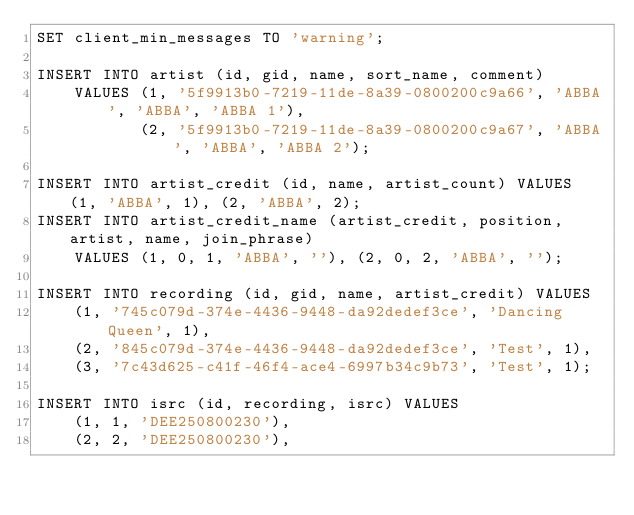Convert code to text. <code><loc_0><loc_0><loc_500><loc_500><_SQL_>SET client_min_messages TO 'warning';

INSERT INTO artist (id, gid, name, sort_name, comment)
    VALUES (1, '5f9913b0-7219-11de-8a39-0800200c9a66', 'ABBA', 'ABBA', 'ABBA 1'),
           (2, '5f9913b0-7219-11de-8a39-0800200c9a67', 'ABBA', 'ABBA', 'ABBA 2');

INSERT INTO artist_credit (id, name, artist_count) VALUES (1, 'ABBA', 1), (2, 'ABBA', 2);
INSERT INTO artist_credit_name (artist_credit, position, artist, name, join_phrase)
    VALUES (1, 0, 1, 'ABBA', ''), (2, 0, 2, 'ABBA', '');

INSERT INTO recording (id, gid, name, artist_credit) VALUES
    (1, '745c079d-374e-4436-9448-da92dedef3ce', 'Dancing Queen', 1),
    (2, '845c079d-374e-4436-9448-da92dedef3ce', 'Test', 1),
    (3, '7c43d625-c41f-46f4-ace4-6997b34c9b73', 'Test', 1);

INSERT INTO isrc (id, recording, isrc) VALUES
    (1, 1, 'DEE250800230'),
    (2, 2, 'DEE250800230'),</code> 